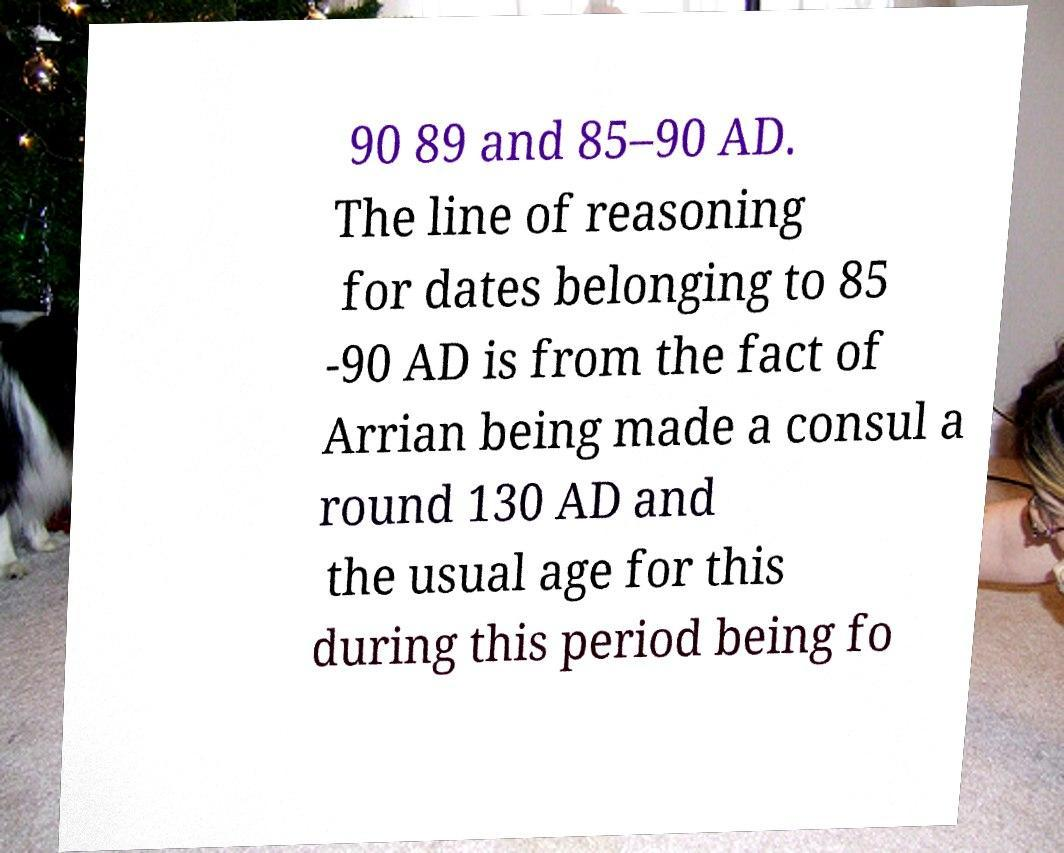Please read and relay the text visible in this image. What does it say? 90 89 and 85–90 AD. The line of reasoning for dates belonging to 85 -90 AD is from the fact of Arrian being made a consul a round 130 AD and the usual age for this during this period being fo 